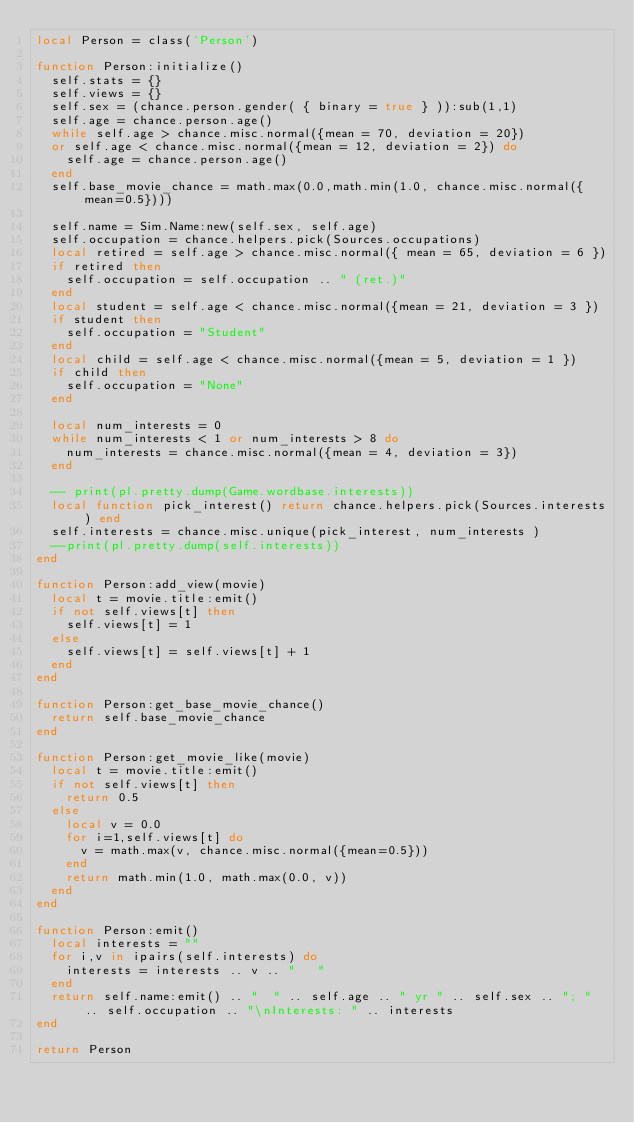Convert code to text. <code><loc_0><loc_0><loc_500><loc_500><_Lua_>local Person = class('Person')

function Person:initialize()
  self.stats = {}
  self.views = {}
  self.sex = (chance.person.gender( { binary = true } )):sub(1,1)
  self.age = chance.person.age()
  while self.age > chance.misc.normal({mean = 70, deviation = 20})
  or self.age < chance.misc.normal({mean = 12, deviation = 2}) do
    self.age = chance.person.age()
  end
  self.base_movie_chance = math.max(0.0,math.min(1.0, chance.misc.normal({mean=0.5})))

  self.name = Sim.Name:new(self.sex, self.age)
  self.occupation = chance.helpers.pick(Sources.occupations)
  local retired = self.age > chance.misc.normal({ mean = 65, deviation = 6 })
  if retired then
    self.occupation = self.occupation .. " (ret.)"
  end
  local student = self.age < chance.misc.normal({mean = 21, deviation = 3 })
  if student then
    self.occupation = "Student"
  end
  local child = self.age < chance.misc.normal({mean = 5, deviation = 1 })
  if child then
    self.occupation = "None"
  end

  local num_interests = 0
  while num_interests < 1 or num_interests > 8 do
    num_interests = chance.misc.normal({mean = 4, deviation = 3})
  end

  -- print(pl.pretty.dump(Game.wordbase.interests))
  local function pick_interest() return chance.helpers.pick(Sources.interests) end
  self.interests = chance.misc.unique(pick_interest, num_interests )
  --print(pl.pretty.dump(self.interests))
end

function Person:add_view(movie)
  local t = movie.title:emit()
  if not self.views[t] then
    self.views[t] = 1
  else
    self.views[t] = self.views[t] + 1
  end
end

function Person:get_base_movie_chance()
  return self.base_movie_chance
end

function Person:get_movie_like(movie)
  local t = movie.title:emit()
  if not self.views[t] then
    return 0.5
  else
    local v = 0.0
    for i=1,self.views[t] do
      v = math.max(v, chance.misc.normal({mean=0.5}))
    end
    return math.min(1.0, math.max(0.0, v))
  end
end

function Person:emit()
  local interests = ""
  for i,v in ipairs(self.interests) do
    interests = interests .. v .. "   "
  end
  return self.name:emit() .. "  " .. self.age .. " yr " .. self.sex .. "; " .. self.occupation .. "\nInterests: " .. interests
end

return Person
</code> 